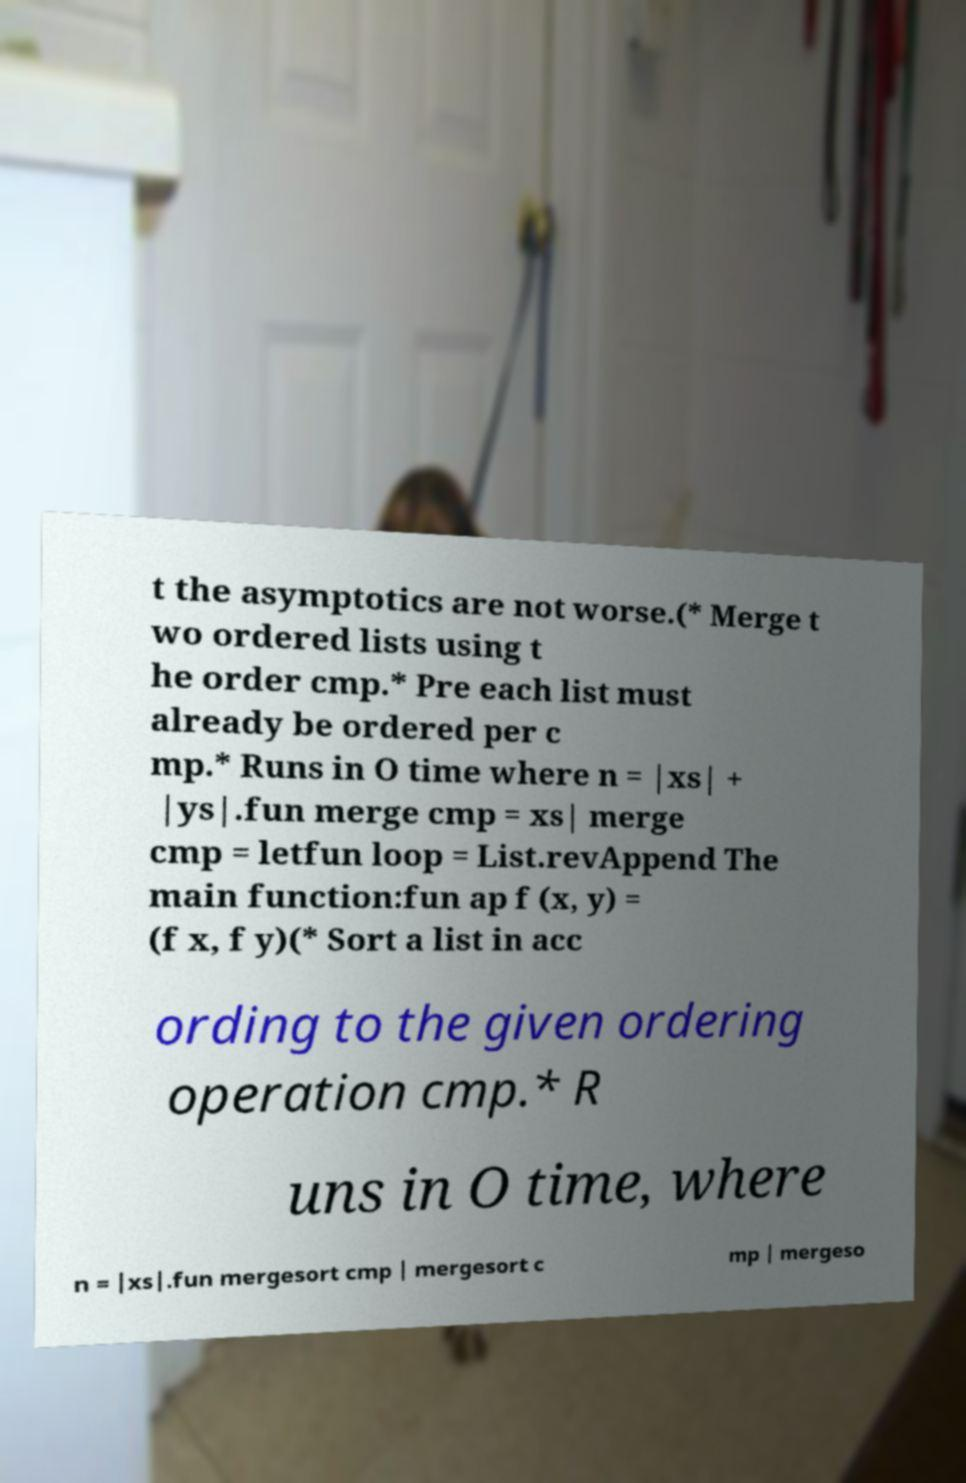What messages or text are displayed in this image? I need them in a readable, typed format. t the asymptotics are not worse.(* Merge t wo ordered lists using t he order cmp.* Pre each list must already be ordered per c mp.* Runs in O time where n = |xs| + |ys|.fun merge cmp = xs| merge cmp = letfun loop = List.revAppend The main function:fun ap f (x, y) = (f x, f y)(* Sort a list in acc ording to the given ordering operation cmp.* R uns in O time, where n = |xs|.fun mergesort cmp | mergesort c mp | mergeso 